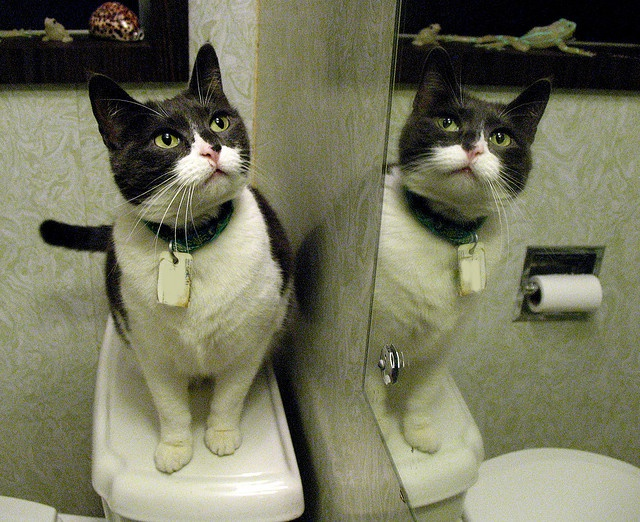Describe the objects in this image and their specific colors. I can see cat in black, olive, darkgray, and gray tones, cat in black, olive, darkgray, and gray tones, toilet in black, lightgray, beige, darkgray, and olive tones, toilet in black, darkgray, beige, and tan tones, and toilet in black, darkgreen, darkgray, gray, and beige tones in this image. 